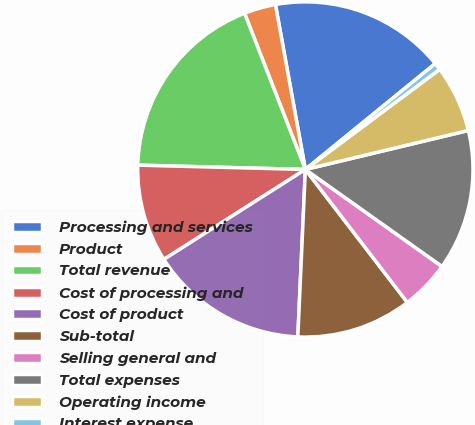Convert chart. <chart><loc_0><loc_0><loc_500><loc_500><pie_chart><fcel>Processing and services<fcel>Product<fcel>Total revenue<fcel>Cost of processing and<fcel>Cost of product<fcel>Sub-total<fcel>Selling general and<fcel>Total expenses<fcel>Operating income<fcel>Interest expense<nl><fcel>16.97%<fcel>3.05%<fcel>18.68%<fcel>9.42%<fcel>15.27%<fcel>11.13%<fcel>4.76%<fcel>13.56%<fcel>6.46%<fcel>0.69%<nl></chart> 